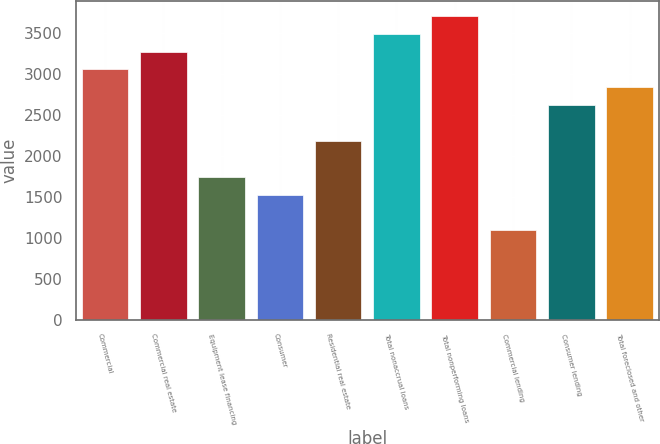Convert chart. <chart><loc_0><loc_0><loc_500><loc_500><bar_chart><fcel>Commercial<fcel>Commercial real estate<fcel>Equipment lease financing<fcel>Consumer<fcel>Residential real estate<fcel>Total nonaccrual loans<fcel>Total nonperforming loans<fcel>Commercial lending<fcel>Consumer lending<fcel>Total foreclosed and other<nl><fcel>3053.36<fcel>3271.44<fcel>1744.88<fcel>1526.8<fcel>2181.04<fcel>3489.52<fcel>3707.6<fcel>1090.64<fcel>2617.2<fcel>2835.28<nl></chart> 